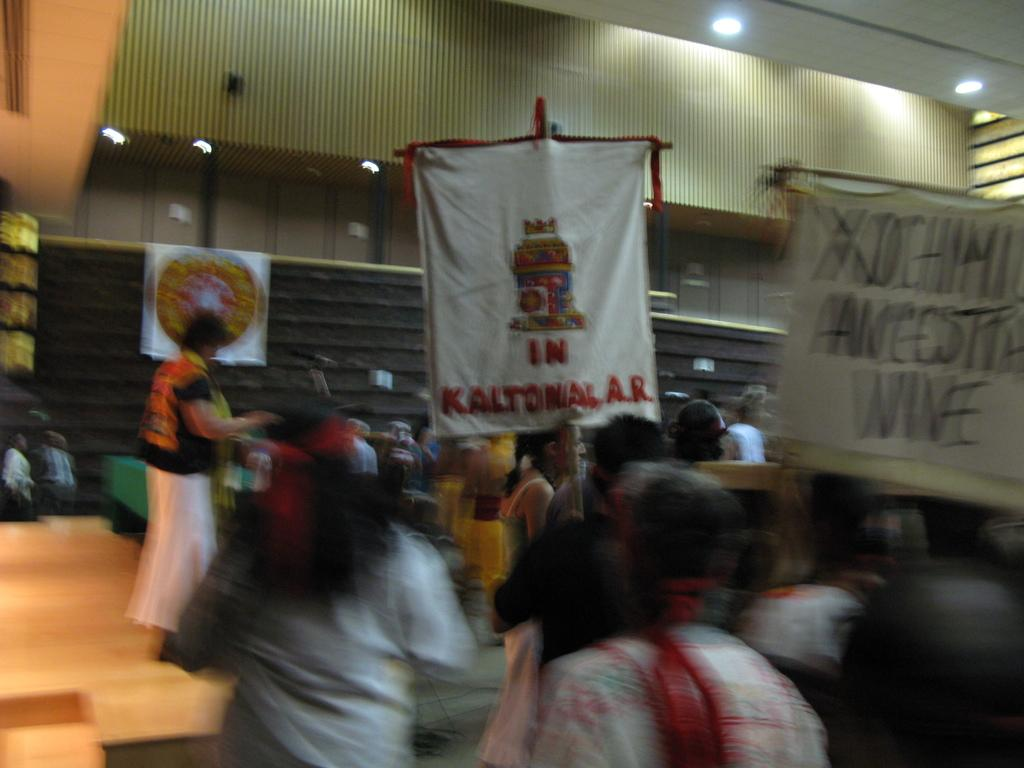How many people are in the image? There are many people in the image. What are the people holding in the image? The people are holding banners and placards in the image. What can be seen on a raised platform in the image? There is a dais in the image, and a person is standing on it. What can be seen in the background of the image? There are walls and lights in the background of the image. Is there snow falling in the image? No, there is no snow present in the image. How many people are in the crowd in the image? The term "crowd" is not mentioned in the facts provided, but there are many people in the image. 